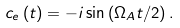Convert formula to latex. <formula><loc_0><loc_0><loc_500><loc_500>c _ { e } \left ( t \right ) = - i \sin \left ( \Omega _ { A } t / 2 \right ) .</formula> 